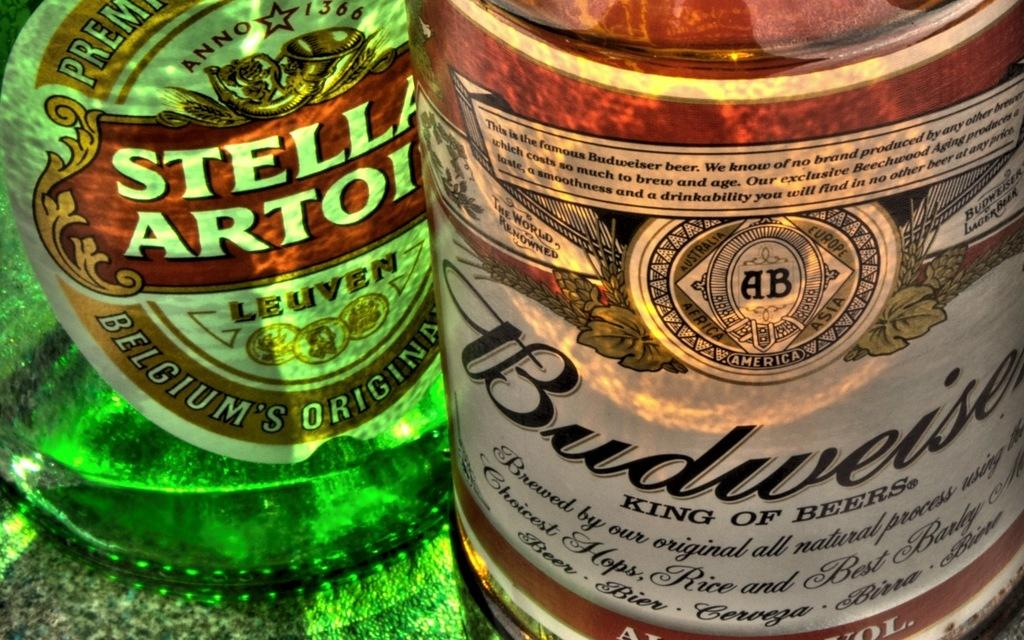How many wine bottles are visible in the image? There are two wine bottles in the image. What colors are the wine bottles? One wine bottle is green, and the other is red. What type of bone can be seen in the bedroom aftermath in the image? There is no bone or bedroom present in the image; it only features two wine bottles. 